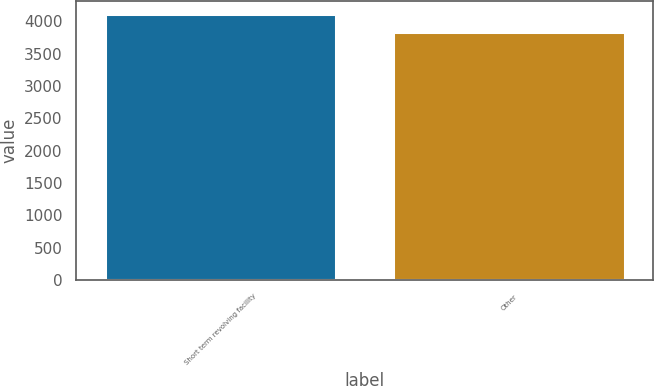<chart> <loc_0><loc_0><loc_500><loc_500><bar_chart><fcel>Short term revolving facility<fcel>Other<nl><fcel>4105.1<fcel>3833<nl></chart> 